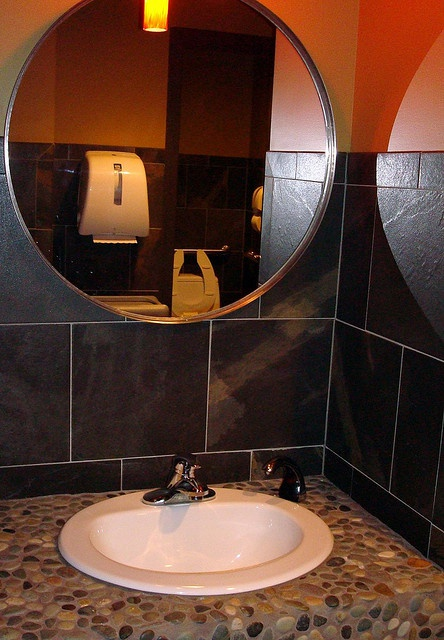Describe the objects in this image and their specific colors. I can see sink in brown and tan tones and toilet in brown, olive, maroon, black, and orange tones in this image. 